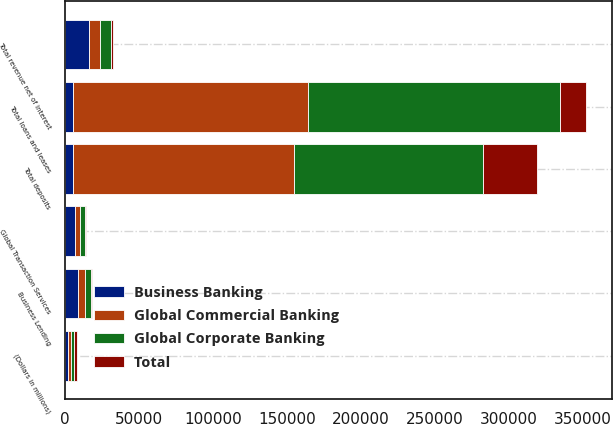Convert chart. <chart><loc_0><loc_0><loc_500><loc_500><stacked_bar_chart><ecel><fcel>(Dollars in millions)<fcel>Business Lending<fcel>Global Transaction Services<fcel>Total revenue net of interest<fcel>Total loans and leases<fcel>Total deposits<nl><fcel>Global Commercial Banking<fcel>2017<fcel>4387<fcel>3322<fcel>7709<fcel>158292<fcel>148704<nl><fcel>Global Corporate Banking<fcel>2017<fcel>4280<fcel>3017<fcel>7297<fcel>170101<fcel>127720<nl><fcel>Total<fcel>2017<fcel>404<fcel>849<fcel>1253<fcel>17682<fcel>36435<nl><fcel>Business Banking<fcel>2017<fcel>9071<fcel>7188<fcel>16259<fcel>5787.5<fcel>5787.5<nl></chart> 